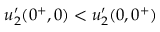<formula> <loc_0><loc_0><loc_500><loc_500>u _ { 2 } ^ { \prime } ( 0 ^ { + } , 0 ) < u _ { 2 } ^ { \prime } ( 0 , 0 ^ { + } )</formula> 